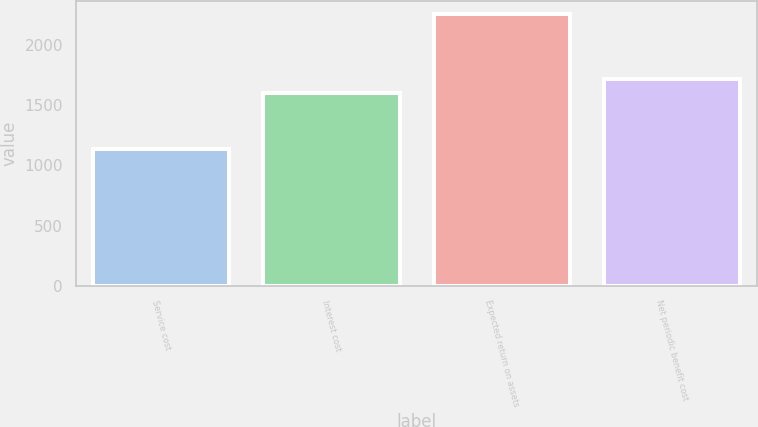Convert chart to OTSL. <chart><loc_0><loc_0><loc_500><loc_500><bar_chart><fcel>Service cost<fcel>Interest cost<fcel>Expected return on assets<fcel>Net periodic benefit cost<nl><fcel>1137<fcel>1604<fcel>2257<fcel>1716<nl></chart> 